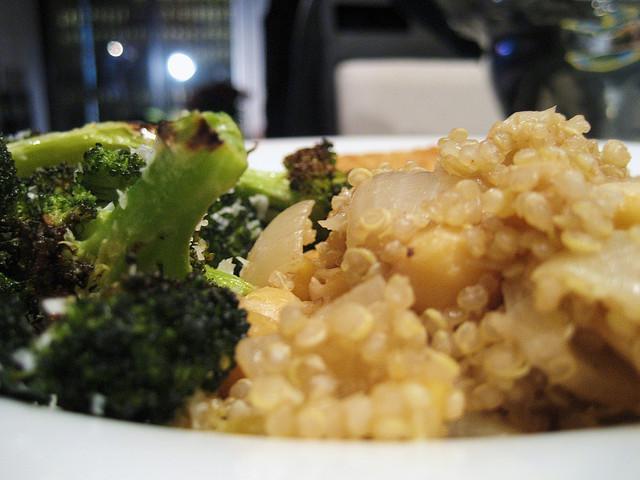How many broccolis are in the photo?
Give a very brief answer. 3. 